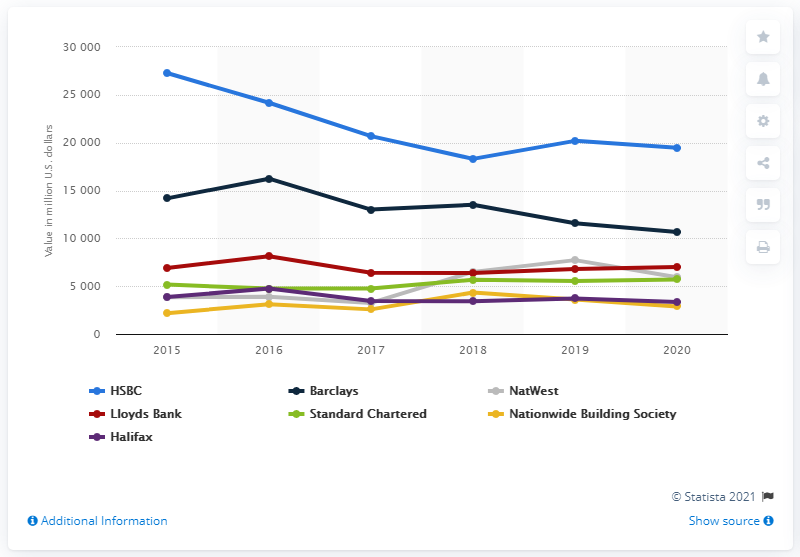List a handful of essential elements in this visual. HSBC was the UK bank with the highest brand value as of December 31, 2019. 